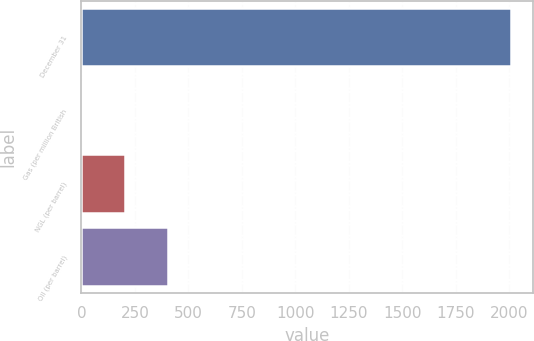Convert chart to OTSL. <chart><loc_0><loc_0><loc_500><loc_500><bar_chart><fcel>December 31<fcel>Gas (per million British<fcel>NGL (per barrel)<fcel>Oil (per barrel)<nl><fcel>2009<fcel>3.87<fcel>204.38<fcel>404.89<nl></chart> 